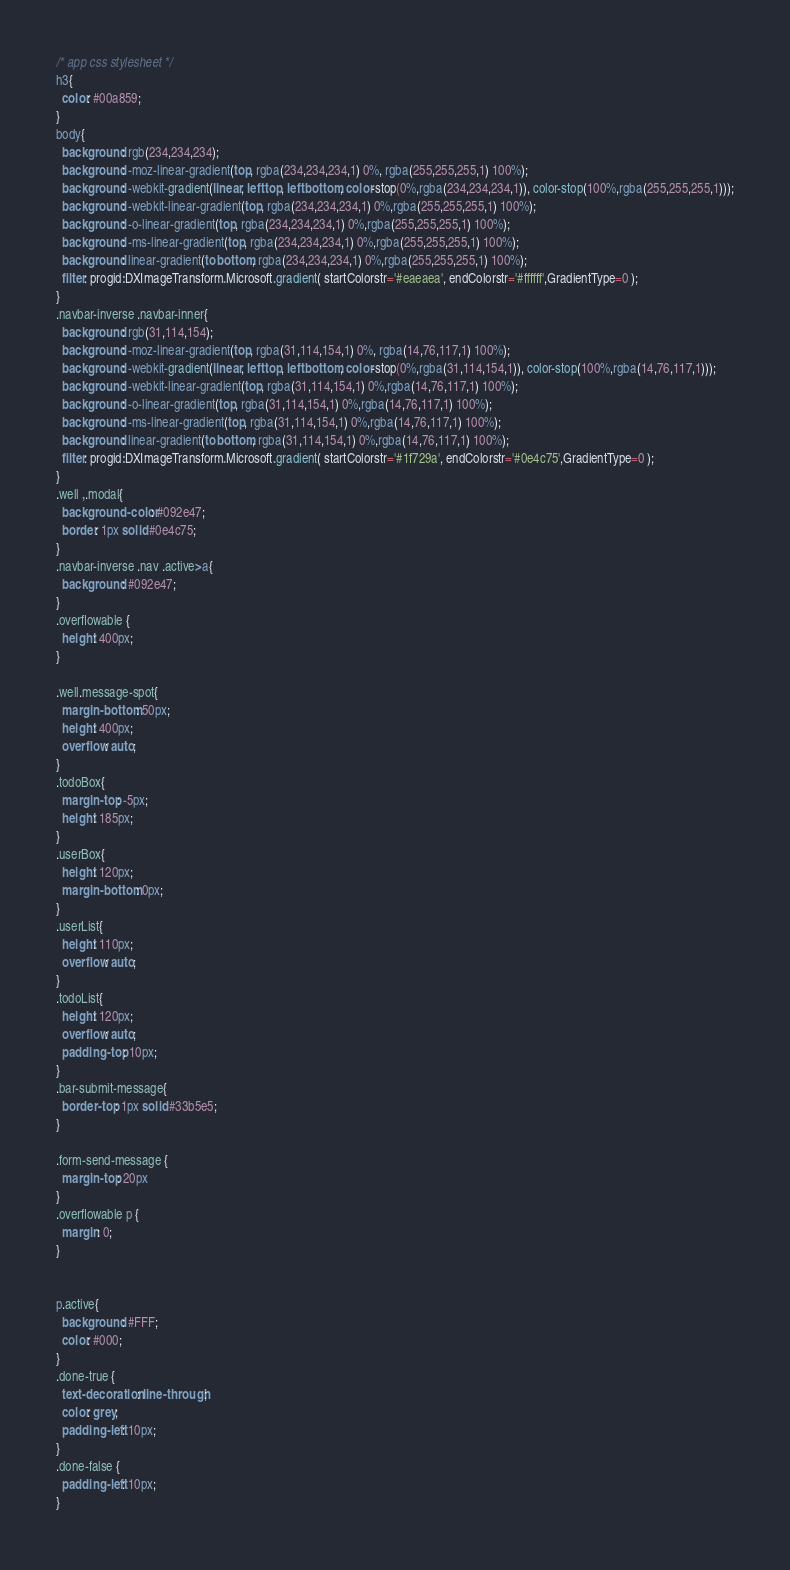<code> <loc_0><loc_0><loc_500><loc_500><_CSS_>/* app css stylesheet */
h3{
  color: #00a859;
}
body{
  background: rgb(234,234,234);
  background: -moz-linear-gradient(top, rgba(234,234,234,1) 0%, rgba(255,255,255,1) 100%);
  background: -webkit-gradient(linear, left top, left bottom, color-stop(0%,rgba(234,234,234,1)), color-stop(100%,rgba(255,255,255,1)));
  background: -webkit-linear-gradient(top, rgba(234,234,234,1) 0%,rgba(255,255,255,1) 100%);
  background: -o-linear-gradient(top, rgba(234,234,234,1) 0%,rgba(255,255,255,1) 100%);
  background: -ms-linear-gradient(top, rgba(234,234,234,1) 0%,rgba(255,255,255,1) 100%);
  background: linear-gradient(to bottom, rgba(234,234,234,1) 0%,rgba(255,255,255,1) 100%);
  filter: progid:DXImageTransform.Microsoft.gradient( startColorstr='#eaeaea', endColorstr='#ffffff',GradientType=0 );
}
.navbar-inverse .navbar-inner{
  background: rgb(31,114,154);
  background: -moz-linear-gradient(top, rgba(31,114,154,1) 0%, rgba(14,76,117,1) 100%);
  background: -webkit-gradient(linear, left top, left bottom, color-stop(0%,rgba(31,114,154,1)), color-stop(100%,rgba(14,76,117,1)));
  background: -webkit-linear-gradient(top, rgba(31,114,154,1) 0%,rgba(14,76,117,1) 100%);
  background: -o-linear-gradient(top, rgba(31,114,154,1) 0%,rgba(14,76,117,1) 100%);
  background: -ms-linear-gradient(top, rgba(31,114,154,1) 0%,rgba(14,76,117,1) 100%);
  background: linear-gradient(to bottom, rgba(31,114,154,1) 0%,rgba(14,76,117,1) 100%);
  filter: progid:DXImageTransform.Microsoft.gradient( startColorstr='#1f729a', endColorstr='#0e4c75',GradientType=0 );
}
.well ,.modal{
  background-color: #092e47;
  border: 1px solid #0e4c75;
}
.navbar-inverse .nav .active>a{
  background: #092e47;
}
.overflowable {
  height: 400px;
}

.well.message-spot{
  margin-bottom: 50px;
  height: 400px;
  overflow: auto;
}
.todoBox{
  margin-top: -5px;
  height: 185px;
}
.userBox{
  height: 120px;
  margin-bottom: 0px;
}
.userList{
  height: 110px;
  overflow: auto;
}
.todoList{
  height: 120px;
  overflow: auto;
  padding-top: 10px;
}
.bar-submit-message{
  border-top: 1px solid #33b5e5;
}

.form-send-message {
  margin-top: 20px
}
.overflowable p {
  margin: 0;
}


p.active{
  background: #FFF;
  color: #000;
}
.done-true {
  text-decoration: line-through;
  color: grey;
  padding-left: 10px;
}
.done-false {
  padding-left: 10px;
}
</code> 